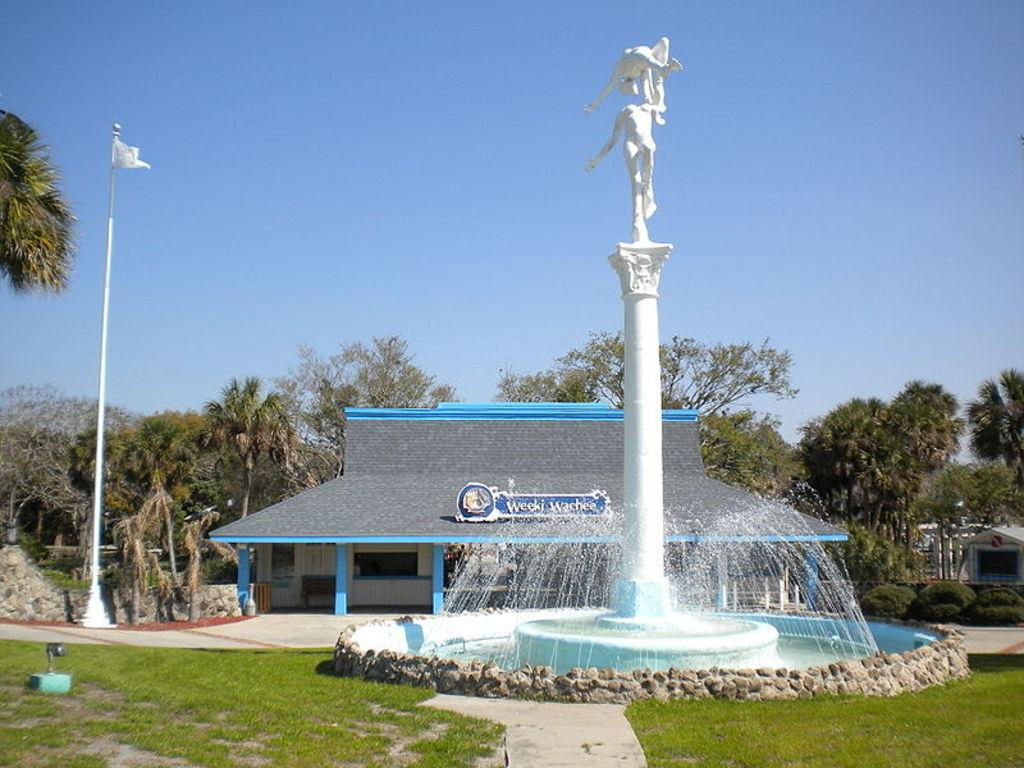What is the main subject in the middle of the water fountain? There is a statue in the middle of the water fountain. What type of vegetation surrounds the statue? There is grass on either side of the statue. What can be seen in the background of the image? There is a home and trees visible in the background. What is visible above the home in the background? The sky is visible above the home. What type of alarm can be heard going off in the image? There is no alarm present or audible in the image. How many dimes are scattered around the statue in the image? There are no dimes present in the image. 